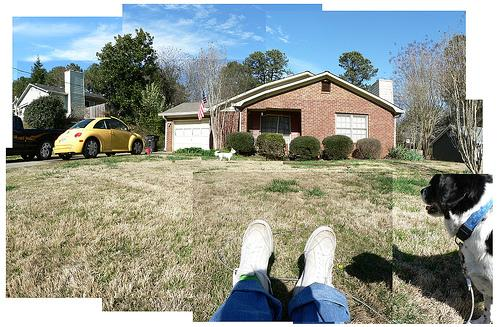Describe the pose of the dog and what it's wearing around its neck. The black and white dog is sitting in the yard and wearing a blue collar. What is unusual about the image and what could be the cause of it? There are mistakes made by the panoramic camera, which pieced the pictures together to form a scene. What state is the grass in and what color is it? The grass is dried and yellow. What kind of surface is covering the house and what is situated on the roof? The house has a brick exterior and there is a chimney for a fireplace on the roof. What type of vehicle is parked in the driveway and what color is it? A yellow Volkswagen Beetle is parked in the driveway. Count the number of dogs and the number of vehicles in the image. There are 2 dogs and 2 vehicles in the image. How would you describe the overall mood of the image? The image has a casual, everyday mood with people and pets enjoying time outside their home. What do the feet of the photographer and the person sitting in the grass have in common? Both are wearing white tennis shoes. Who is wearing white shoes and what are they doing? A person wearing white tennis shoes is sitting in the grass. What items in the image indicate that the house is American? An American flag is attached to the house and the yard has water-starved front lawn. Is the American flag on the house pink and covered with stars? The image information shows an American flag attached to the house, but it does not indicate the color pink or any additional stars. This instruction is misleading because it misrepresents the flag's appearance. Identify the objects and their boundaries near the legs of the person sitting in the grass. There are white shoes at X: 232 Y: 207 Width: 121 Height: 121 and cuffs of blue jeans at X: 230 Y: 268 Width: 126 Height: 126. Estimate the quality of the image based on the mistakes made by the panoramic camera. The image quality is affected by minor mistake at X:385 Y:170 Width:18 Height:18. How does the front lawn appear in the image? Water starved, dried, and yellow grass. What types of bushes are in front of the house? Green bushes are at X:233 Y:127 Width:155 Height:155. Is there anything unusual about the image? There is a mistake made by the panoramic camera at X:385 Y:170 Width:18 Height:18. Describe the interaction between the person and the lawn. The person is sitting in the grass, which is water-starved and dried. Identify the location and characteristics of the house with a brick exterior. The house is located at X:161 Y:69 Width:238 Height:238 with brick exterior, chimney, large window, and an American flag. Explain the interaction between the person and the dog in the scene. The person is sitting in the grass near the black and white dog. What type of pants is the person wearing and what do they look like? The person is wearing blue jeans with rolled-up cuffs. What color is the dog's collar? The dog has a blue collar. Are the bushes in front of the house orange instead of green? No, it's not mentioned in the image. Find anomalies and their positions in the image. Mistakes made by panoramic camera at X:385 Y:170 Width:18 Height:18 and blue sky anomaly at X:315 Y:17 Width:62 Height:62. Is the person wearing green pants sitting on the grass? The image information states that the person has blue pants, not green pants. This instruction is misleading because it suggests an incorrect color for the pants. Describe the vehicles in the image. There are a yellow Volkswagen Beetle and a smaller black pickup parked in the driveway. Does the black and white dog have a red collar? The image information mentions a dog with a blue collar, not a red collar. This instruction is misleading because it introduces false information about the dog's collar color. What additional objects are part of the scene in the driveway? Yellow Beetle, black pickup, and an overhead garage door. Please transcribe any text visible within the image. There is no visible text in the image. List the object attributes and their positions for the white dog. The white dog is at X:213 Y:146 Width:22 Height:22 and it's sitting on the dried yellow grass. Locate the large window on the side of the house. X:315 Y:111 Width:67 Height:67 Can you find the purple Volkswagen Beetle in the driveway? The image information describes a yellow Volkswagen Beetle, not a purple one. This instruction is misleading because it suggests a different color for the car that does not exist in the image. Is there any anomaly in the blue sky's position? The blue sky anomaly is at X: 315 Y: 17 Width: 62 Height: 62. Is the small dog on the lawn blue instead of white? The image information states that there is a small white dog on the lawn, but this instruction implies that the dog might be blue. This is misleading because it provides false information about the dog's color. Detect objects in the image next to the American flag attached to the house. A chimney for a fireplace is located at X:368 Y:76 Width:27 Height:27 and an attic's air vent at X:317 Y:71 Width:16 Height:16. Identify the position and dimensions of the American flag. X:197 Y:91 Width:11 Height:11 